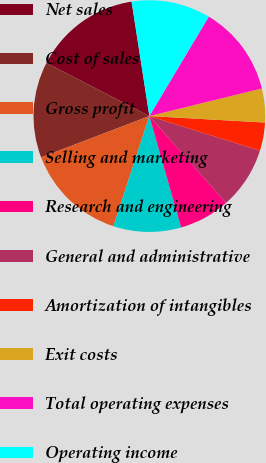Convert chart. <chart><loc_0><loc_0><loc_500><loc_500><pie_chart><fcel>Net sales<fcel>Cost of sales<fcel>Gross profit<fcel>Selling and marketing<fcel>Research and engineering<fcel>General and administrative<fcel>Amortization of intangibles<fcel>Exit costs<fcel>Total operating expenses<fcel>Operating income<nl><fcel>14.96%<fcel>13.39%<fcel>14.17%<fcel>9.45%<fcel>7.09%<fcel>8.66%<fcel>3.94%<fcel>4.72%<fcel>12.6%<fcel>11.02%<nl></chart> 